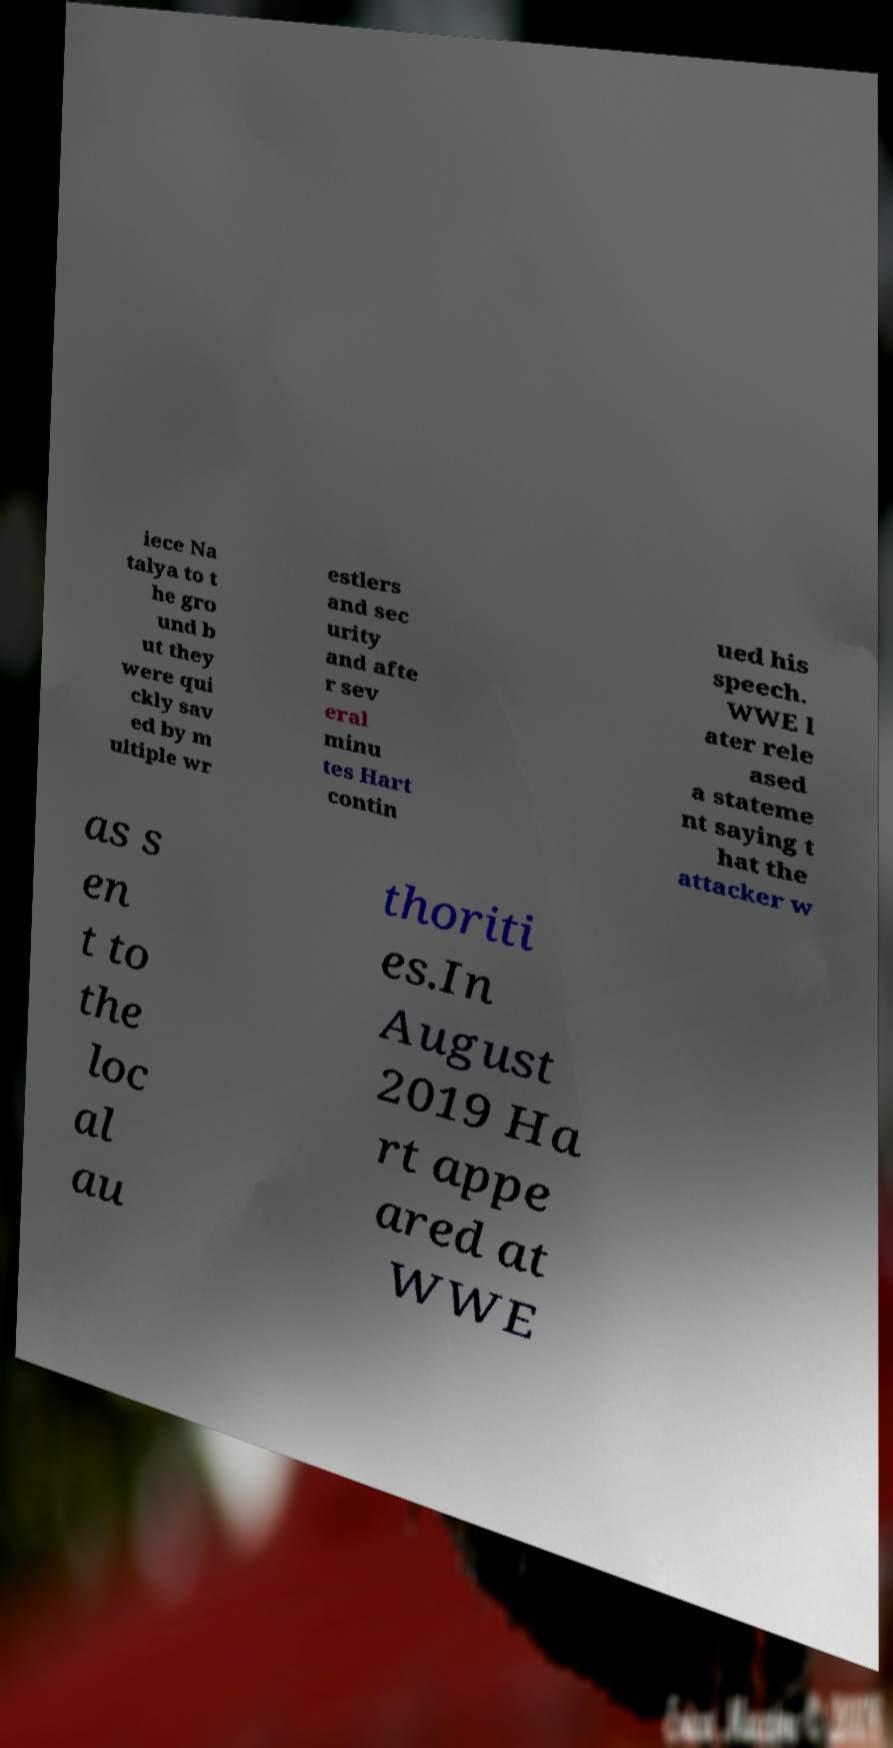Please read and relay the text visible in this image. What does it say? iece Na talya to t he gro und b ut they were qui ckly sav ed by m ultiple wr estlers and sec urity and afte r sev eral minu tes Hart contin ued his speech. WWE l ater rele ased a stateme nt saying t hat the attacker w as s en t to the loc al au thoriti es.In August 2019 Ha rt appe ared at WWE 